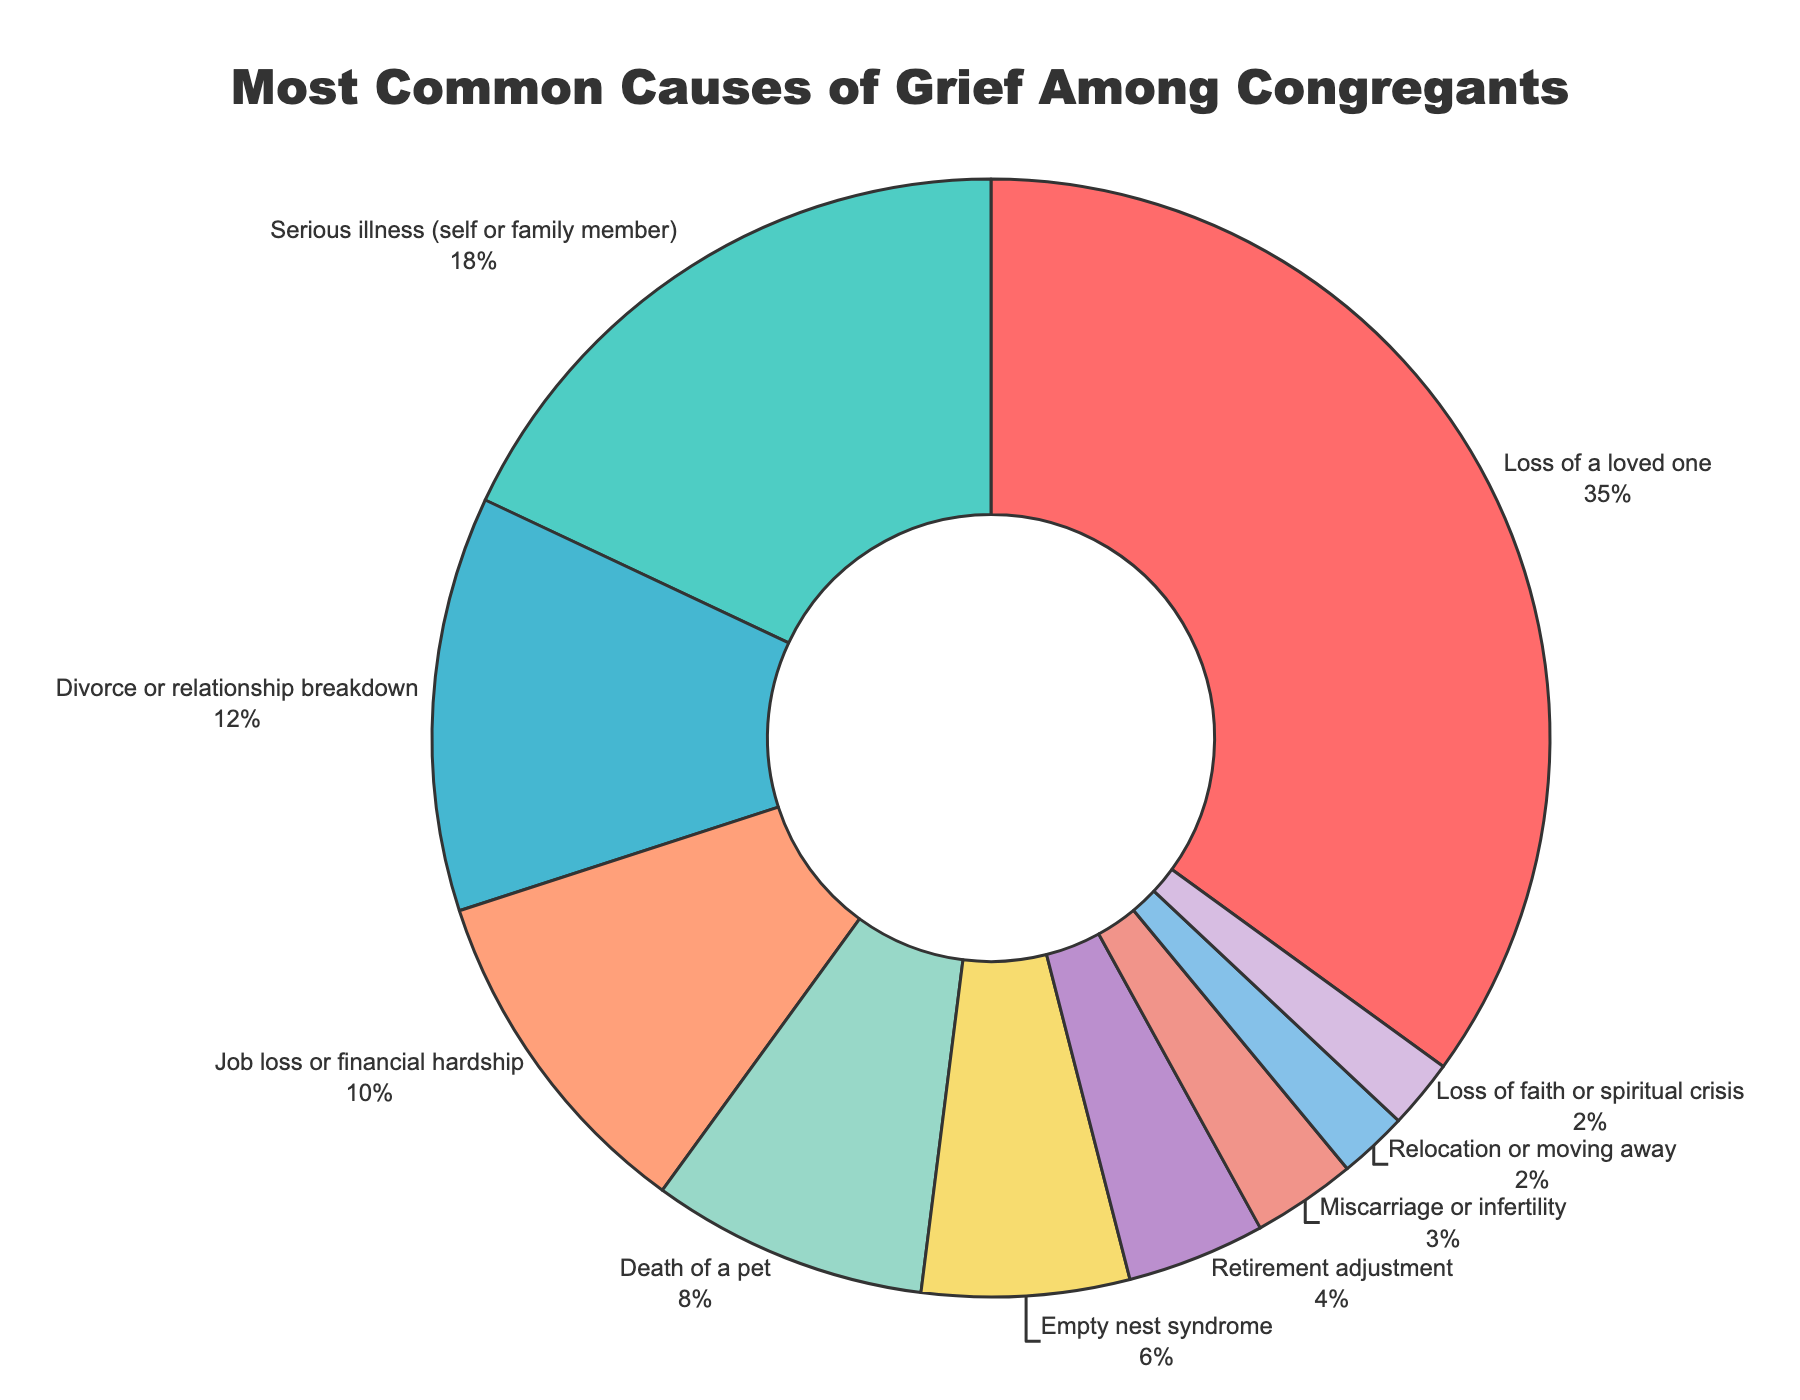What is the most common cause of grief among congregants, according to the pie chart? The pie chart indicates that the largest segment, representing 35%, is associated with the cause "Loss of a loved one". This is depicted by the largest slice of the pie chart.
Answer: Loss of a loved one Which two causes of grief have the smallest percentages? The smallest segments are those labeled "Relocation or moving away" and "Loss of faith or spiritual crisis", each with a share of 2%. These segments are depicted as the smallest slices of the pie chart.
Answer: Relocation or moving away, Loss of faith or spiritual crisis What is the combined percentage of grief caused by "Serious illness (self or family member)" and "Divorce or relationship breakdown"? The pie chart shows that "Serious illness (self or family member)" accounts for 18% and "Divorce or relationship breakdown" accounts for 12%. Adding these together gives 18% + 12% = 30%.
Answer: 30% How much more common is grief associated with "Loss of a loved one" compared to "Job loss or financial hardship"? Grief caused by "Loss of a loved one" (35%) is 25% more common than grief caused by "Job loss or financial hardship" (10%). This is calculated by subtracting 10% from 35%.
Answer: 25% Which cause of grief has nearly half the percentage compared to "Loss of a loved one"? According to the pie chart, "Serious illness (self or family member)" is at 18%, which is nearly half of 35% (the percentage for "Loss of a loved one").
Answer: Serious illness (self or family member) What is the total percentage for causes of grief related to life transitions such as "Empty nest syndrome", "Retirement adjustment", and "Relocation or moving away"? The percentages for "Empty nest syndrome" is 6%, "Retirement adjustment" is 4%, and "Relocation or moving away" is 2%. Summing these gives 6% + 4% + 2% = 12%.
Answer: 12% Compare the percentage of grief caused by "Death of a pet" to "Miscarriage or infertility". The pie chart shows the percentage for "Death of a pet" is 8%, whereas for "Miscarriage or infertility" it is only 3%. Therefore, grief from "Death of a pet" is 5% more common.
Answer: 5% more What color represents the segment for "Divorce or relationship breakdown" in the pie chart, and what is its percentage? In the pie chart, “Divorce or relationship breakdown” is typically represented by the third segment color and it shows a percentage of 12%.
Answer: 12% How does the visual size of the segment for "Retirement adjustment" compare to that for "Death of a pet"? The segment for "Retirement adjustment" (4%) is smaller than that for "Death of a pet" (8%). This is visually evident as the slice representing "Retirement adjustment" occupies less space in the pie chart.
Answer: It is smaller 